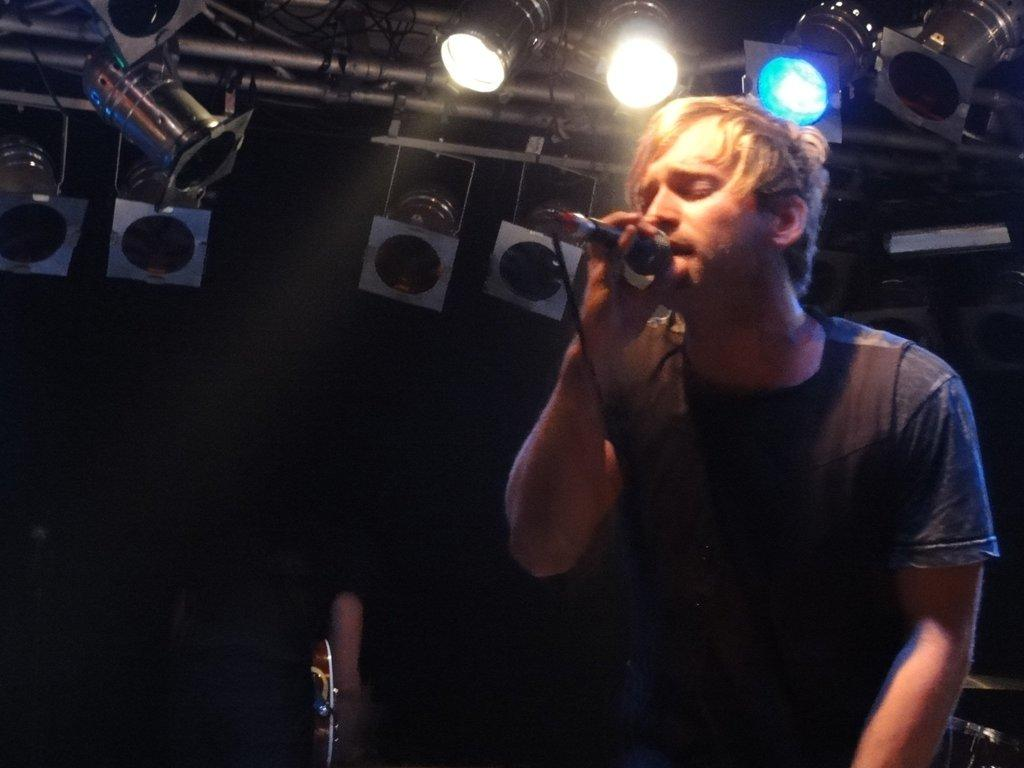What is the man in the image holding? The man is holding a mic with his hand. What can be seen in the background of the image? There are lights, rods, and some objects in the background of the image. How would you describe the lighting in the image? The background of the image is dark. What type of leather is being used to divide the objects in the image? There is no leather or division of objects present in the image. What type of oil can be seen dripping from the lights in the image? There is no oil or dripping substance visible in the image. 